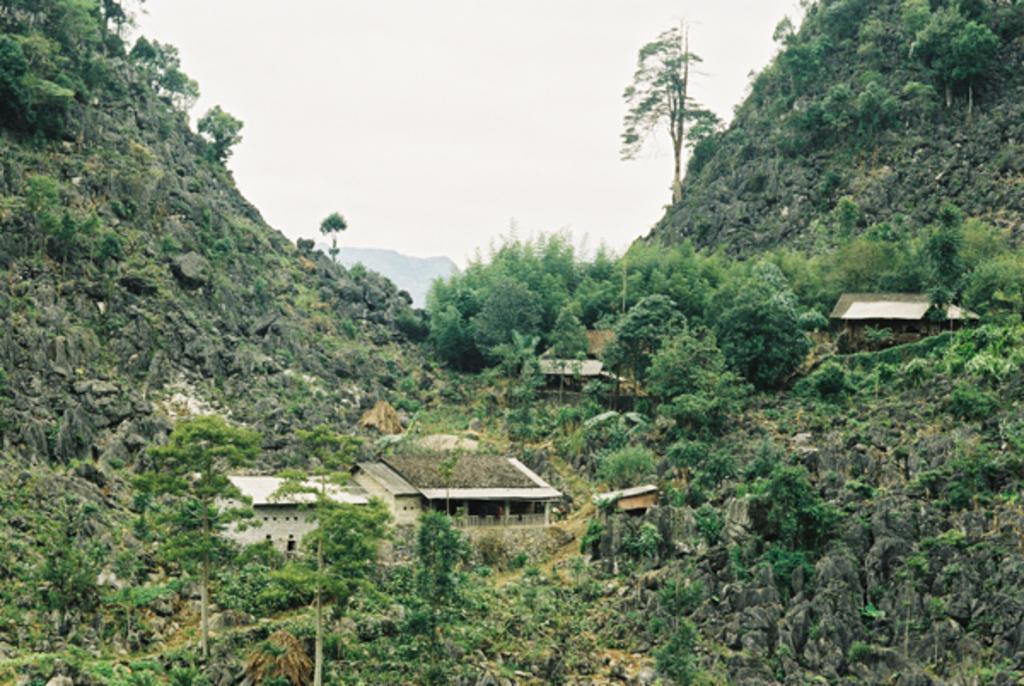Could you give a brief overview of what you see in this image? In the image we can see some trees and hills and buildings. At the top of the image there are some clouds and sky. 